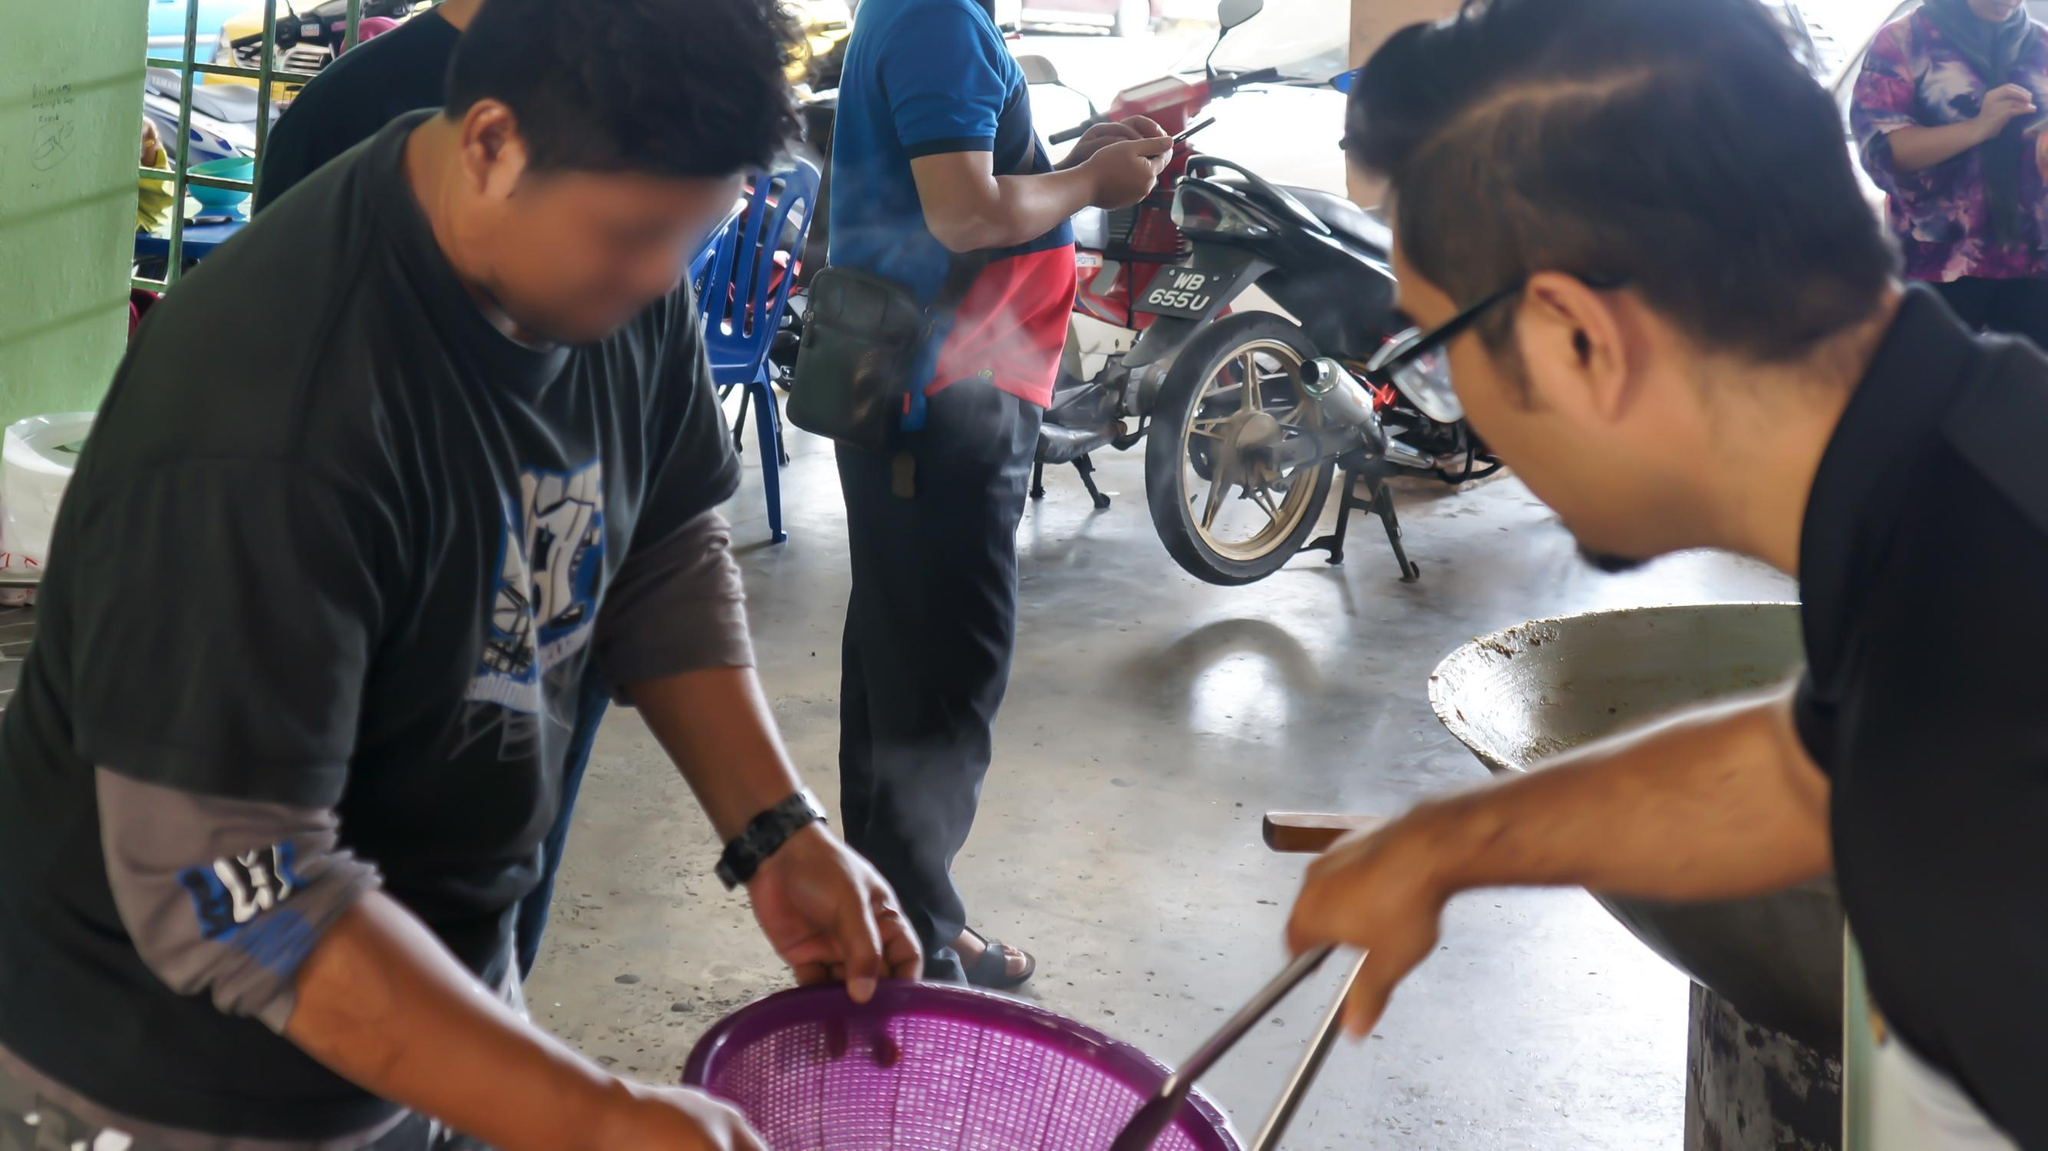Can you tell anything about the location or setting from this image? The setting of the image suggests a busy marketplace, possibly in a tropical or subtropical location given the clothing style and motorbikes, which are common in many parts of Asia. The semi-open structure of the place, with a roof overhead, indicates a setting designed to protect from the sun or rain while allowing air circulation. The casual attire of the individuals and their relaxed yet focused demeanors hint at a location where open-air markets are an integral part of daily life. However, specifics about the exact geographic location cannot be determined from the image alone. 